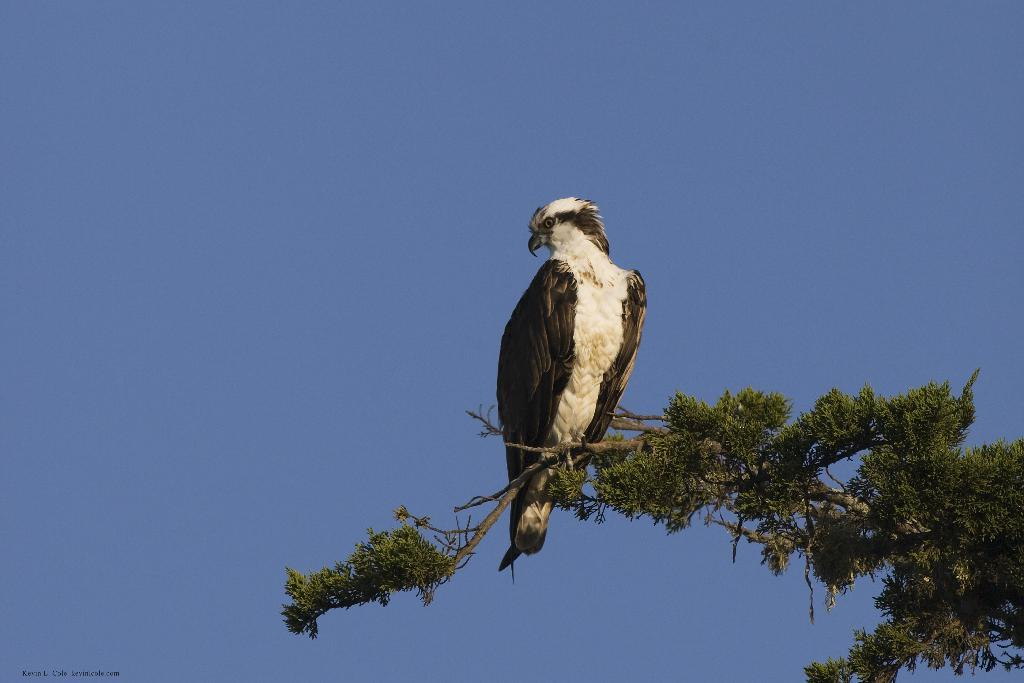What type of animal can be seen in the image? There is a bird in the image. Where is the bird located? The bird is on a tree. What can be seen in the background of the image? There is sky visible in the background of the image. What type of education does the bird receive in the image? There is no indication in the image that the bird is receiving any education. 